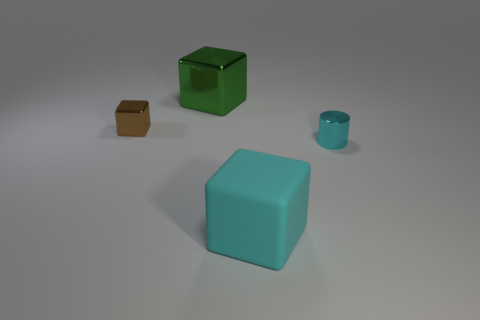Are there any other things that are made of the same material as the cyan cube?
Your response must be concise. No. The green metallic block is what size?
Keep it short and to the point. Large. Are there any other big green things that have the same material as the big green object?
Keep it short and to the point. No. There is a cyan object that is the same shape as the small brown object; what size is it?
Offer a terse response. Large. Are there the same number of green metal cubes that are on the right side of the big matte object and shiny objects?
Provide a succinct answer. No. There is a metallic thing to the right of the large metallic block; is its shape the same as the small brown metal thing?
Give a very brief answer. No. The rubber object has what shape?
Your answer should be very brief. Cube. What material is the small object left of the big object that is in front of the small metal block that is in front of the green metal object made of?
Offer a terse response. Metal. What material is the tiny object that is the same color as the rubber cube?
Offer a terse response. Metal. How many things are either tiny brown metallic objects or big cyan metallic objects?
Your answer should be very brief. 1. 